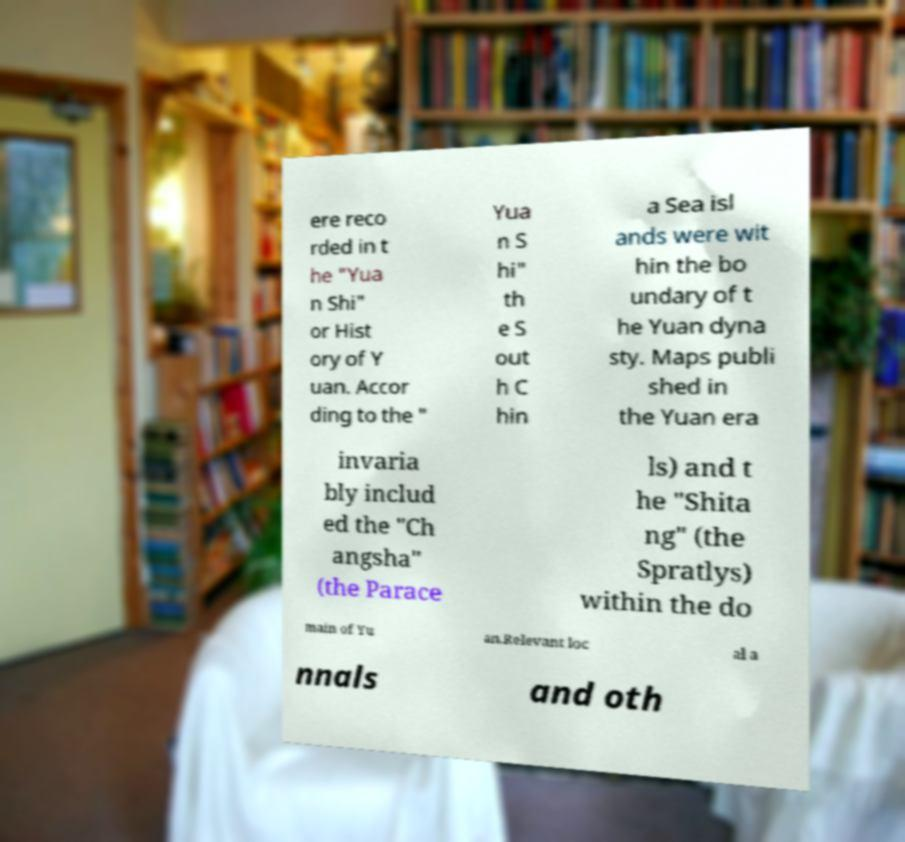Can you read and provide the text displayed in the image?This photo seems to have some interesting text. Can you extract and type it out for me? ere reco rded in t he "Yua n Shi" or Hist ory of Y uan. Accor ding to the " Yua n S hi" th e S out h C hin a Sea isl ands were wit hin the bo undary of t he Yuan dyna sty. Maps publi shed in the Yuan era invaria bly includ ed the "Ch angsha" (the Parace ls) and t he "Shita ng" (the Spratlys) within the do main of Yu an.Relevant loc al a nnals and oth 